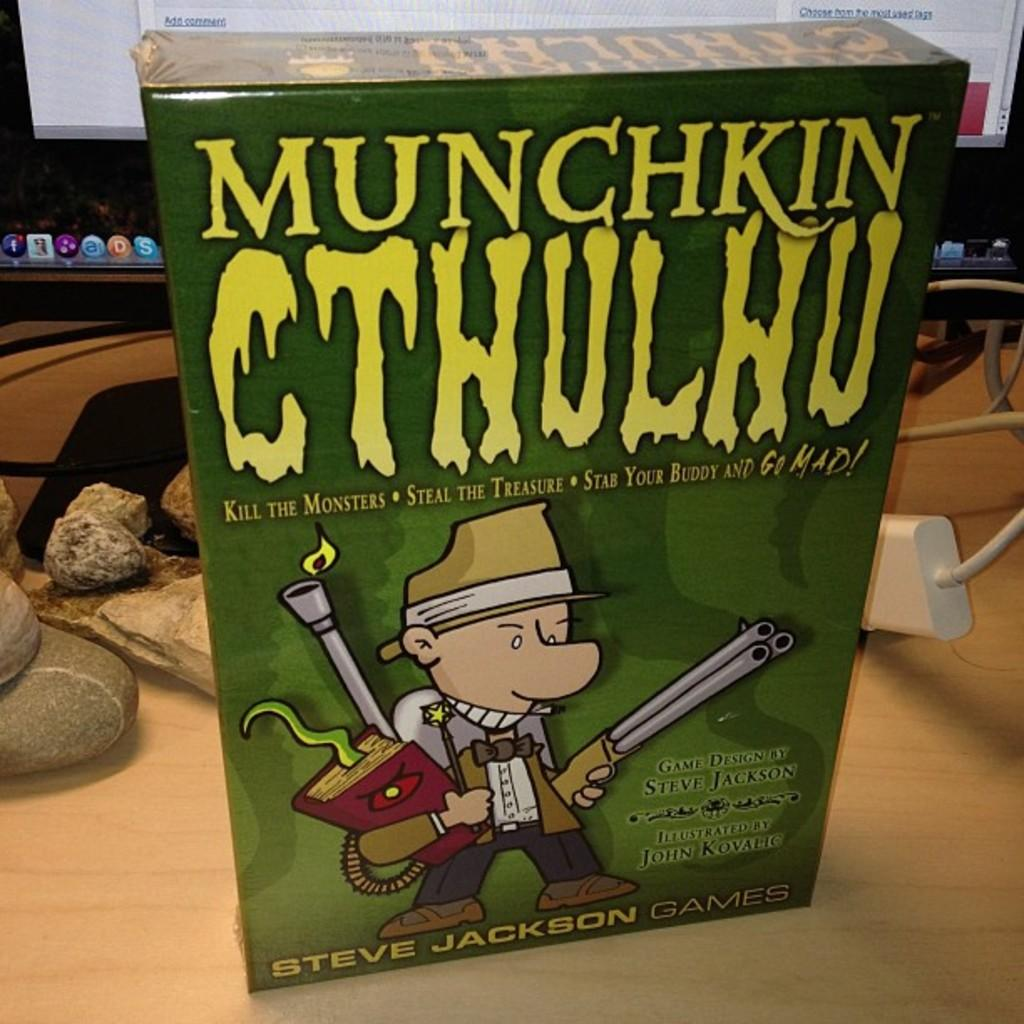<image>
Describe the image concisely. The box for a computer game shows a cartoon character carrying a gun beneath the title Munchkin Cthulhu 